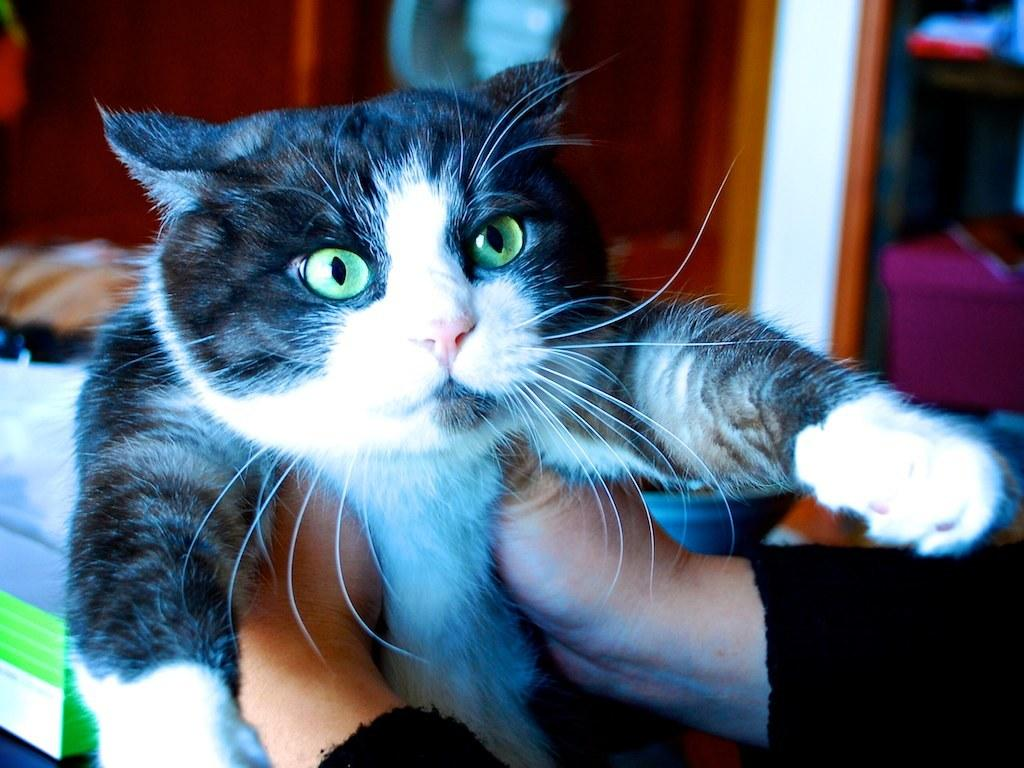What is the main subject in the foreground of the image? There is a person in the foreground of the image. What is the person holding in the image? The person is holding a cat. Can you describe any other objects or elements in the background of the image? There are other objects in the background of the image, but their specific details are not mentioned in the provided facts. What type of blood is visible on the coat in the image? There is no mention of blood or a coat in the provided facts, so we cannot answer this question based on the image. 